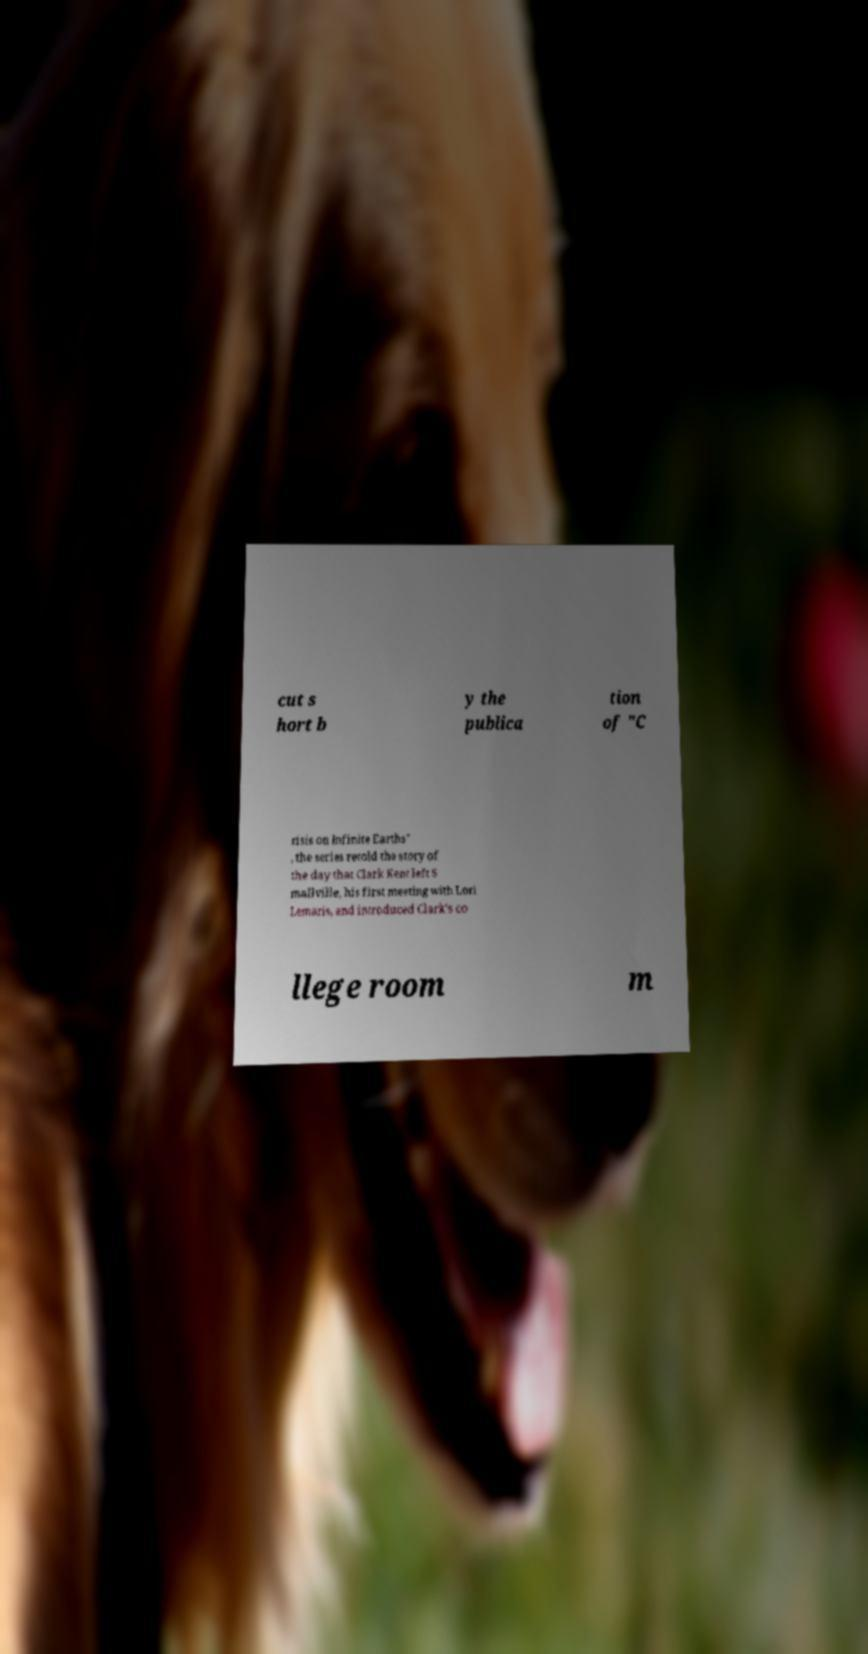Please identify and transcribe the text found in this image. cut s hort b y the publica tion of "C risis on Infinite Earths" , the series retold the story of the day that Clark Kent left S mallville, his first meeting with Lori Lemaris, and introduced Clark's co llege room m 